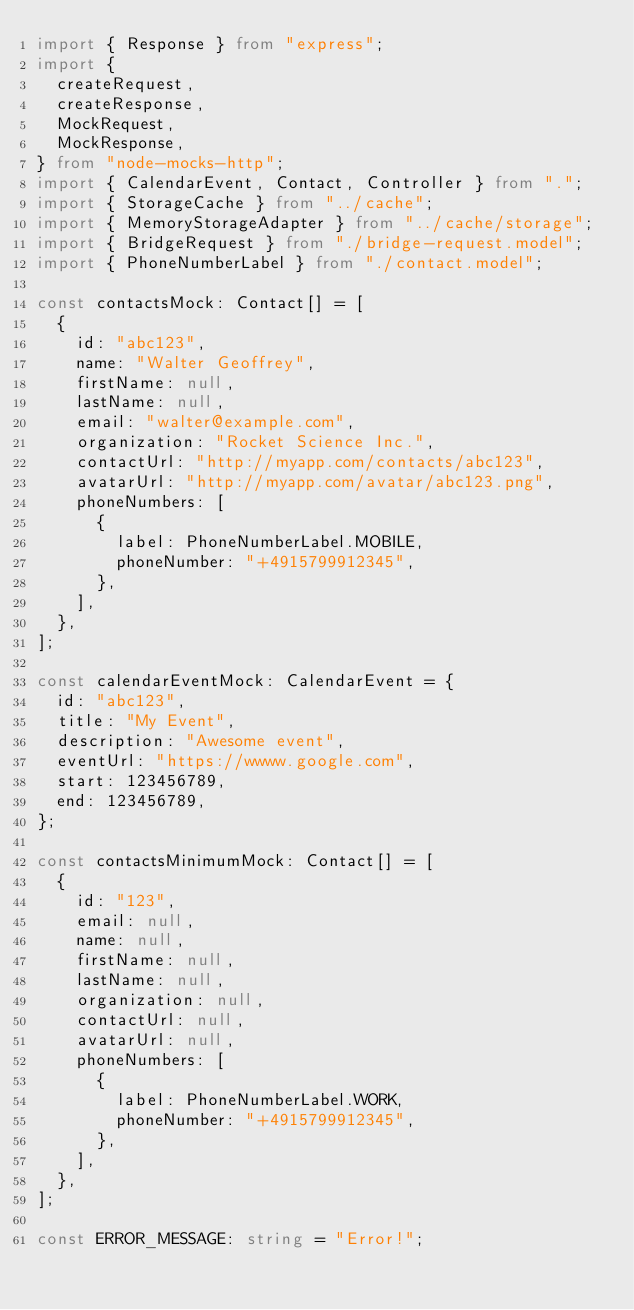Convert code to text. <code><loc_0><loc_0><loc_500><loc_500><_TypeScript_>import { Response } from "express";
import {
  createRequest,
  createResponse,
  MockRequest,
  MockResponse,
} from "node-mocks-http";
import { CalendarEvent, Contact, Controller } from ".";
import { StorageCache } from "../cache";
import { MemoryStorageAdapter } from "../cache/storage";
import { BridgeRequest } from "./bridge-request.model";
import { PhoneNumberLabel } from "./contact.model";

const contactsMock: Contact[] = [
  {
    id: "abc123",
    name: "Walter Geoffrey",
    firstName: null,
    lastName: null,
    email: "walter@example.com",
    organization: "Rocket Science Inc.",
    contactUrl: "http://myapp.com/contacts/abc123",
    avatarUrl: "http://myapp.com/avatar/abc123.png",
    phoneNumbers: [
      {
        label: PhoneNumberLabel.MOBILE,
        phoneNumber: "+4915799912345",
      },
    ],
  },
];

const calendarEventMock: CalendarEvent = {
  id: "abc123",
  title: "My Event",
  description: "Awesome event",
  eventUrl: "https://wwww.google.com",
  start: 123456789,
  end: 123456789,
};

const contactsMinimumMock: Contact[] = [
  {
    id: "123",
    email: null,
    name: null,
    firstName: null,
    lastName: null,
    organization: null,
    contactUrl: null,
    avatarUrl: null,
    phoneNumbers: [
      {
        label: PhoneNumberLabel.WORK,
        phoneNumber: "+4915799912345",
      },
    ],
  },
];

const ERROR_MESSAGE: string = "Error!";
</code> 